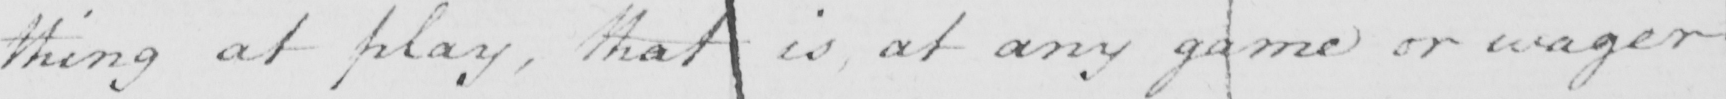What text is written in this handwritten line? thing at play , that is , at any game or wager 